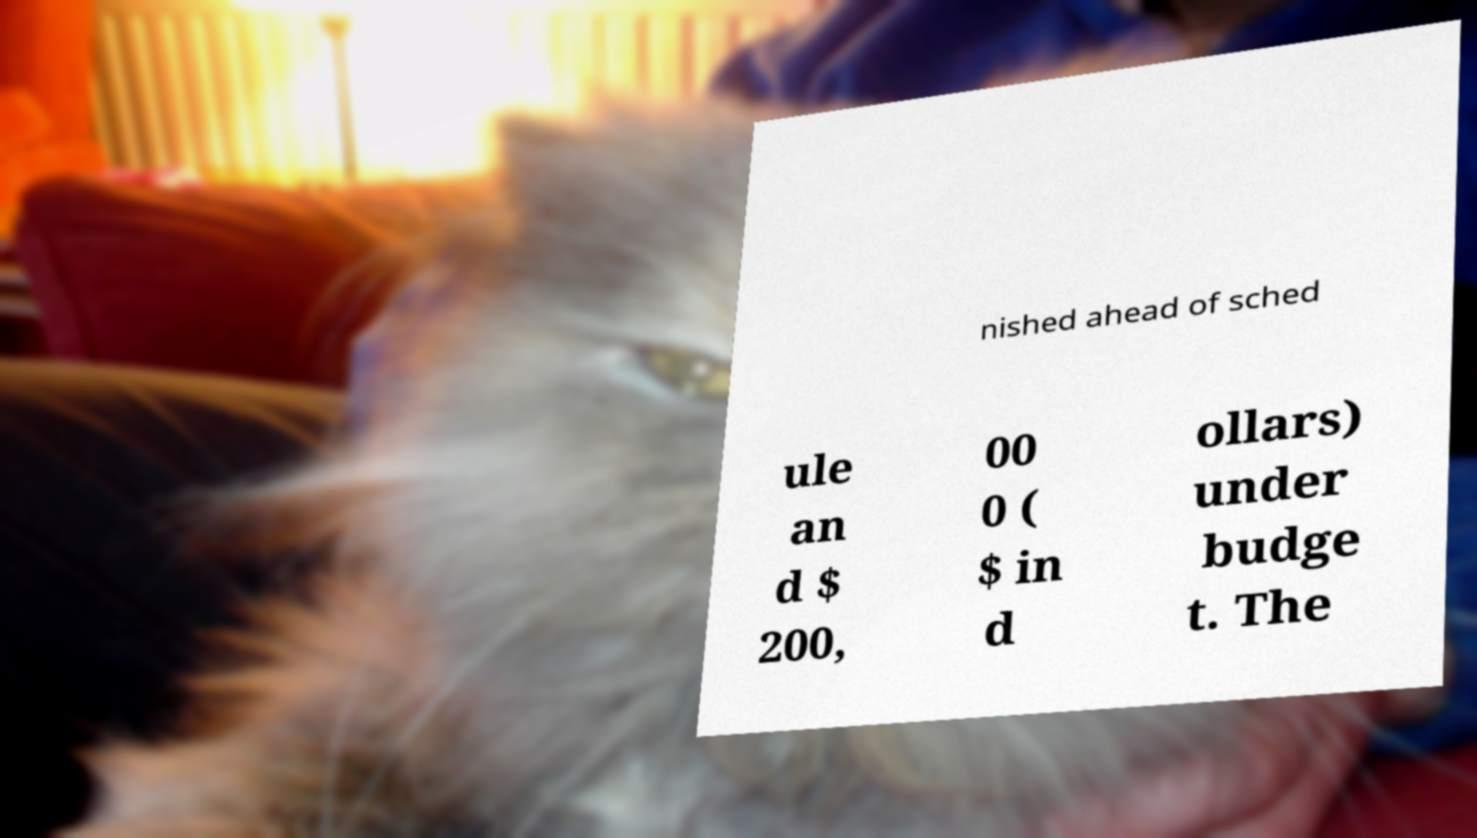What messages or text are displayed in this image? I need them in a readable, typed format. nished ahead of sched ule an d $ 200, 00 0 ( $ in d ollars) under budge t. The 